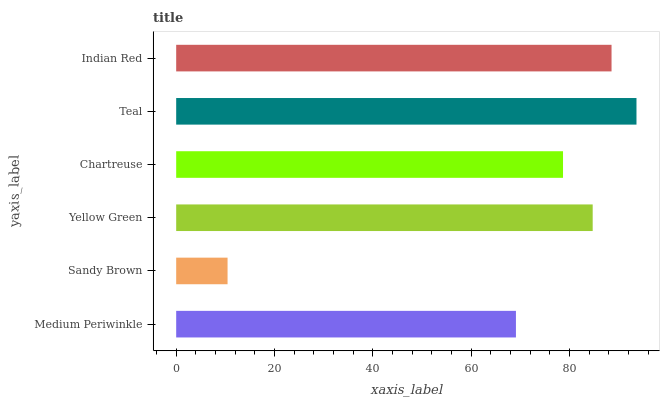Is Sandy Brown the minimum?
Answer yes or no. Yes. Is Teal the maximum?
Answer yes or no. Yes. Is Yellow Green the minimum?
Answer yes or no. No. Is Yellow Green the maximum?
Answer yes or no. No. Is Yellow Green greater than Sandy Brown?
Answer yes or no. Yes. Is Sandy Brown less than Yellow Green?
Answer yes or no. Yes. Is Sandy Brown greater than Yellow Green?
Answer yes or no. No. Is Yellow Green less than Sandy Brown?
Answer yes or no. No. Is Yellow Green the high median?
Answer yes or no. Yes. Is Chartreuse the low median?
Answer yes or no. Yes. Is Indian Red the high median?
Answer yes or no. No. Is Indian Red the low median?
Answer yes or no. No. 